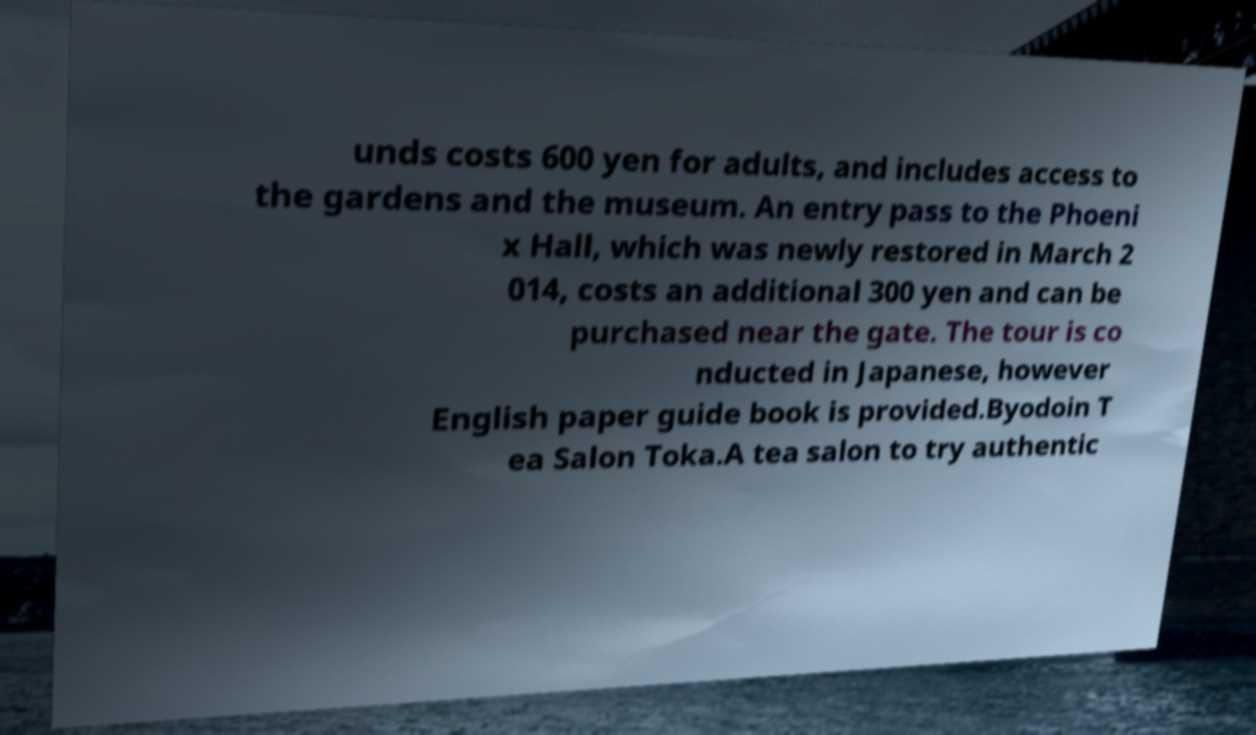Please read and relay the text visible in this image. What does it say? unds costs 600 yen for adults, and includes access to the gardens and the museum. An entry pass to the Phoeni x Hall, which was newly restored in March 2 014, costs an additional 300 yen and can be purchased near the gate. The tour is co nducted in Japanese, however English paper guide book is provided.Byodoin T ea Salon Toka.A tea salon to try authentic 